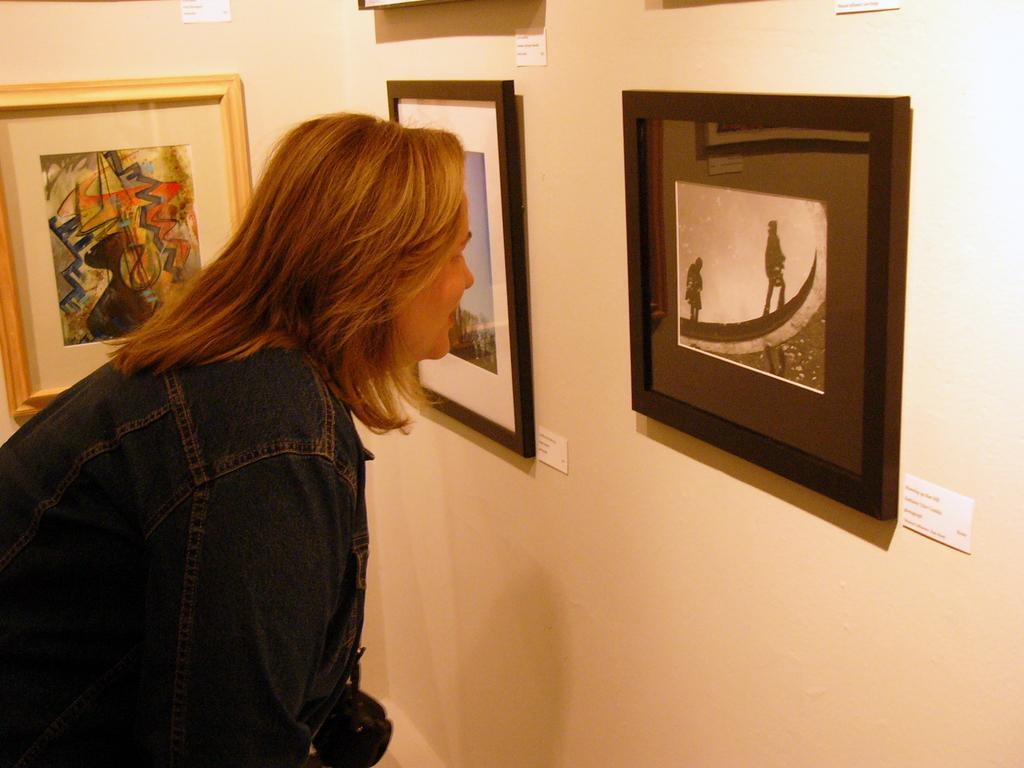Who is on the left side of the image? There is a lady on the left side of the image. What can be seen in the background of the image? There is a wall in the image. What is on the wall in the image? There are photo frames with paintings on the wall. How many roses are on the chair in the image? There is no chair or rose present in the image. What type of bird can be seen perched on the wren in the image? There is no bird or wren present in the image. 